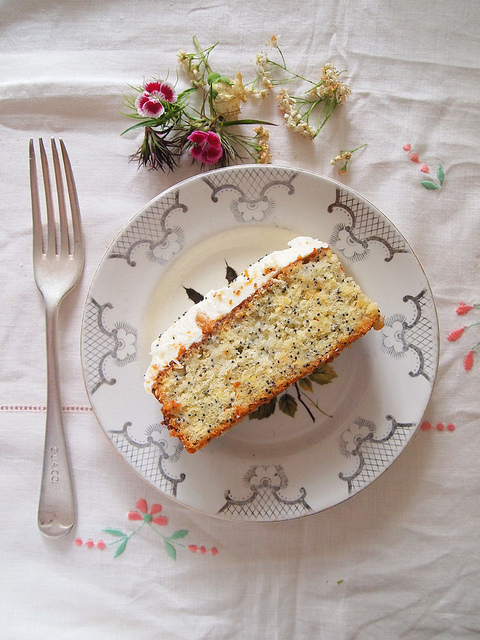What can you infer about the occasion or setting of this image? Judging by the tasteful presentation of the slice of cake on a decorative plate, alongside a carefully placed fork and a lovely flower arrangement, it can be inferred that this image is capturing a moment from a special occasion or a formal setting. This meticulous arrangement suggests a celebration or a gathering, emphasizing a moment of indulgence or commemoration. 